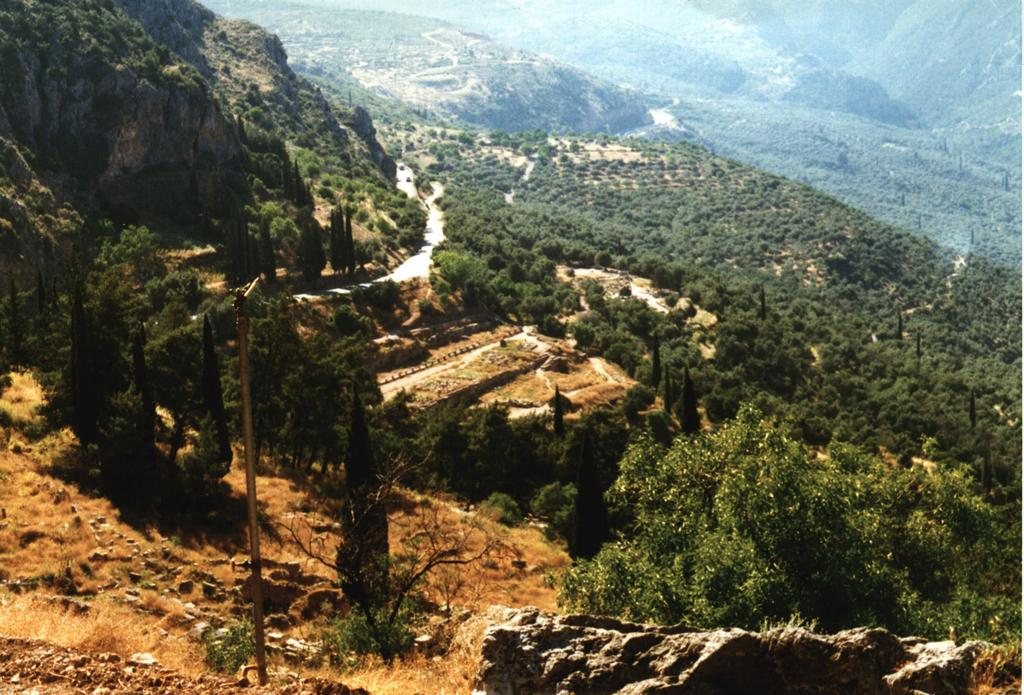What type of natural formation can be seen in the image? There are mountains in the image. What type of vegetation is present in the image? There are trees in the image. Where is the pole located in the image? The pole is on the left side of the image. What objects are near the pole? There are stones and a plant beside the pole. What can be seen in the center of the image? There is a road in the center of the image. Who is the owner of the cabbage in the image? There is no cabbage present in the image. Where is the faucet located in the image? There is no faucet present in the image. 